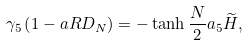<formula> <loc_0><loc_0><loc_500><loc_500>\gamma _ { 5 } \left ( 1 - a R D _ { N } \right ) = - \tanh \frac { N } { 2 } a _ { 5 } \widetilde { H } ,</formula> 